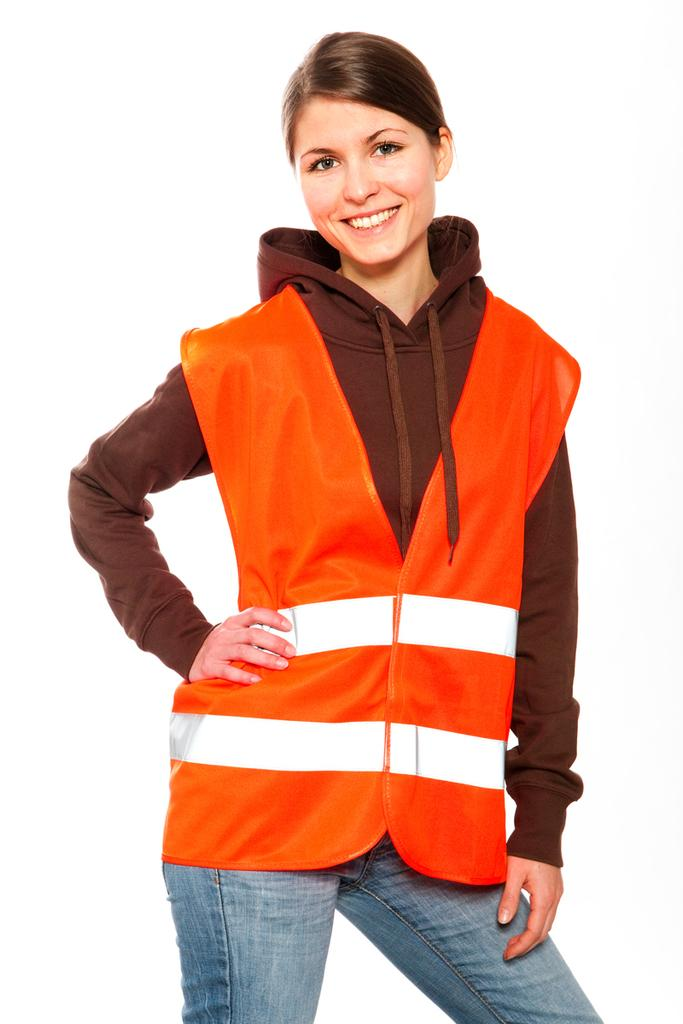Who is the main subject in the image? There is a woman in the image. What is the woman doing in the image? The woman is standing and smiling. What is the color of the background in the image? The background of the image is white in color. How many men are wishing for the woman's care in the image? There are no men present in the image, and therefore no such wishes can be observed. 